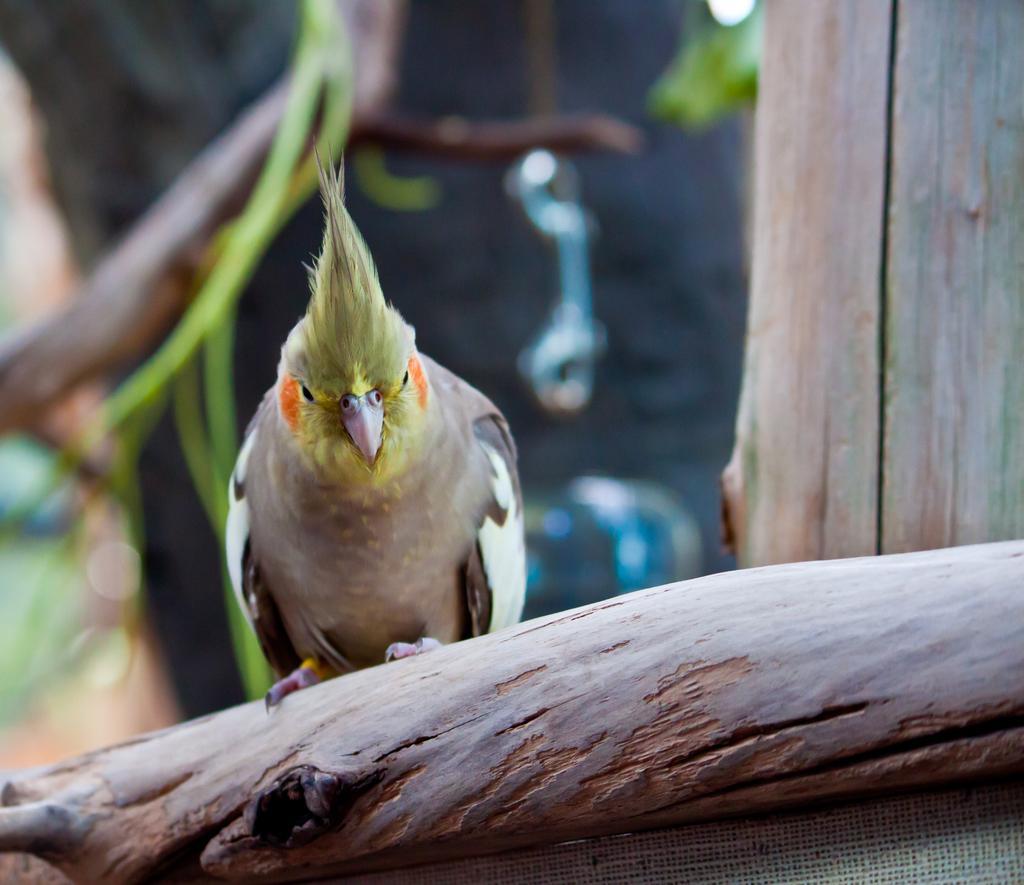Please provide a concise description of this image. In the foreground of the picture there is a parrot on the trunk of a tree. On the right there is a trunk. The background is blurred. 